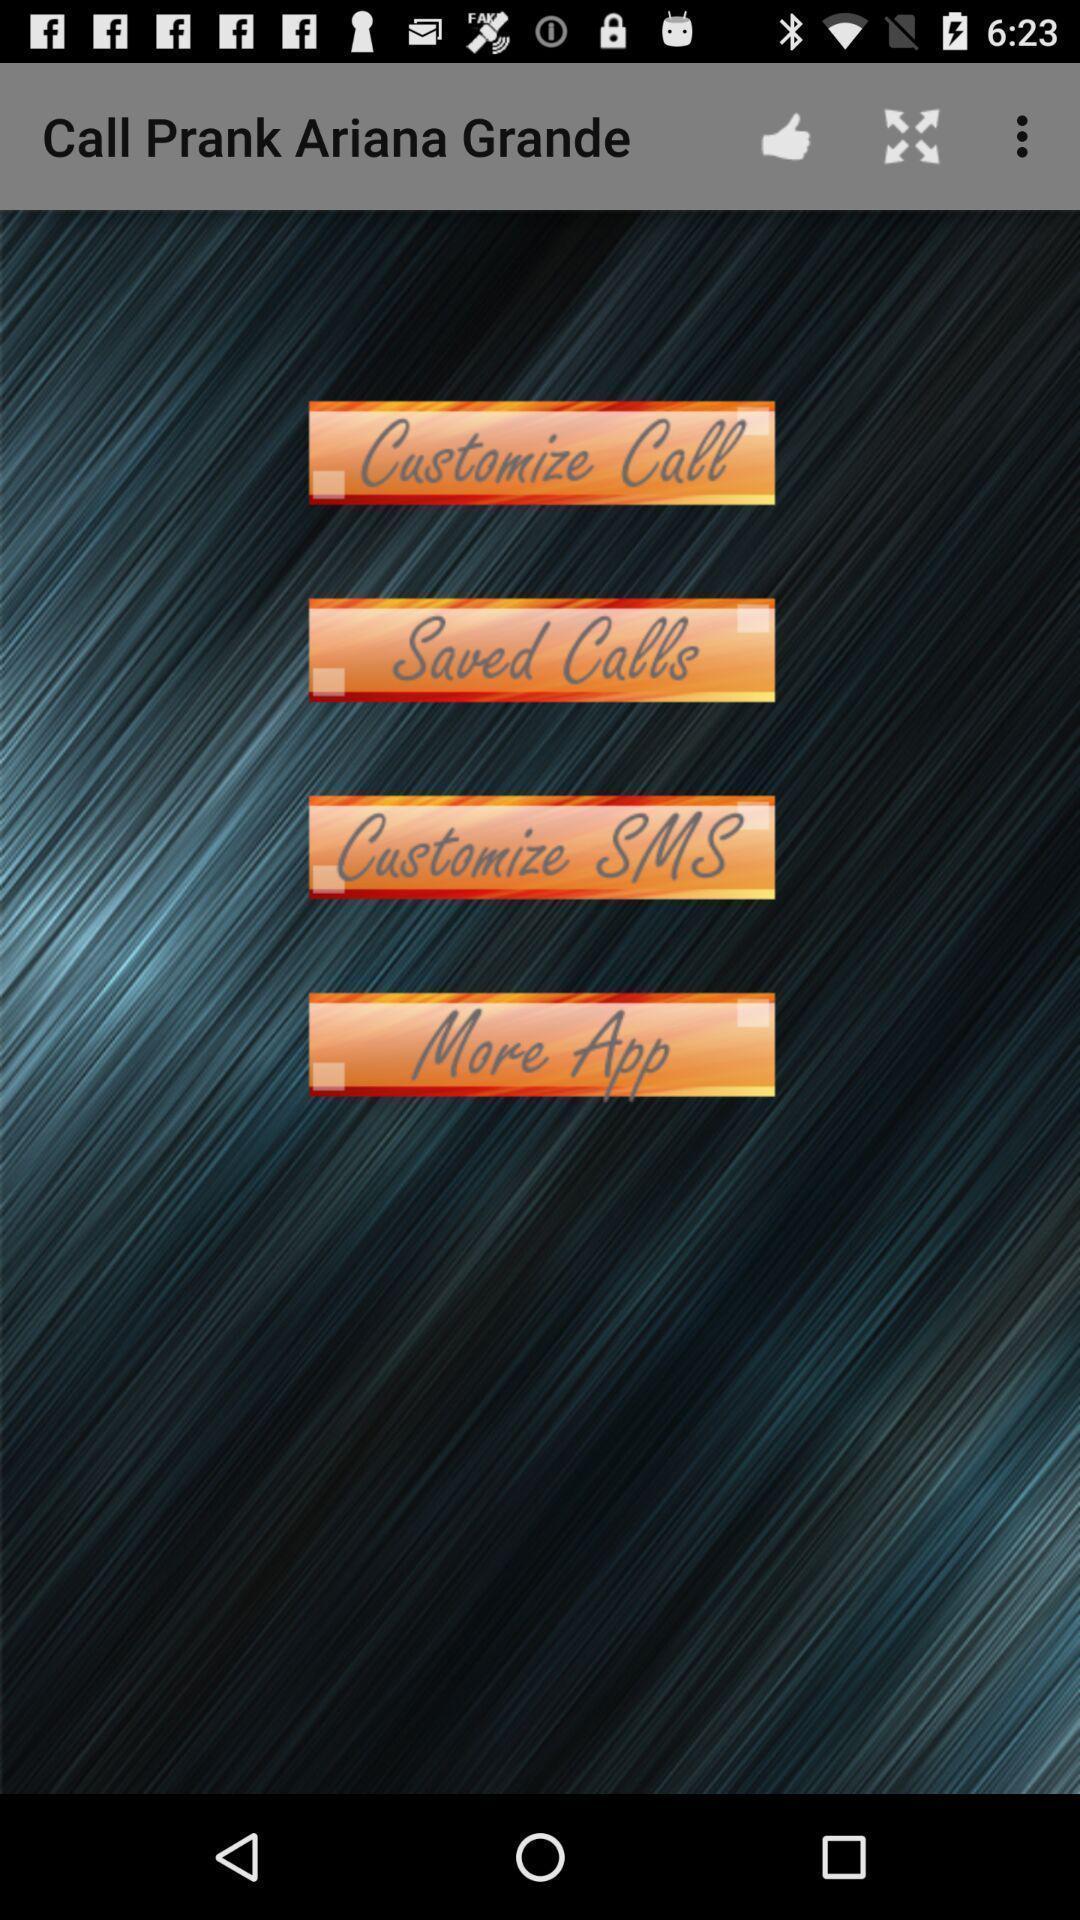Describe the visual elements of this screenshot. Screen showing list of calls from a prank application. 